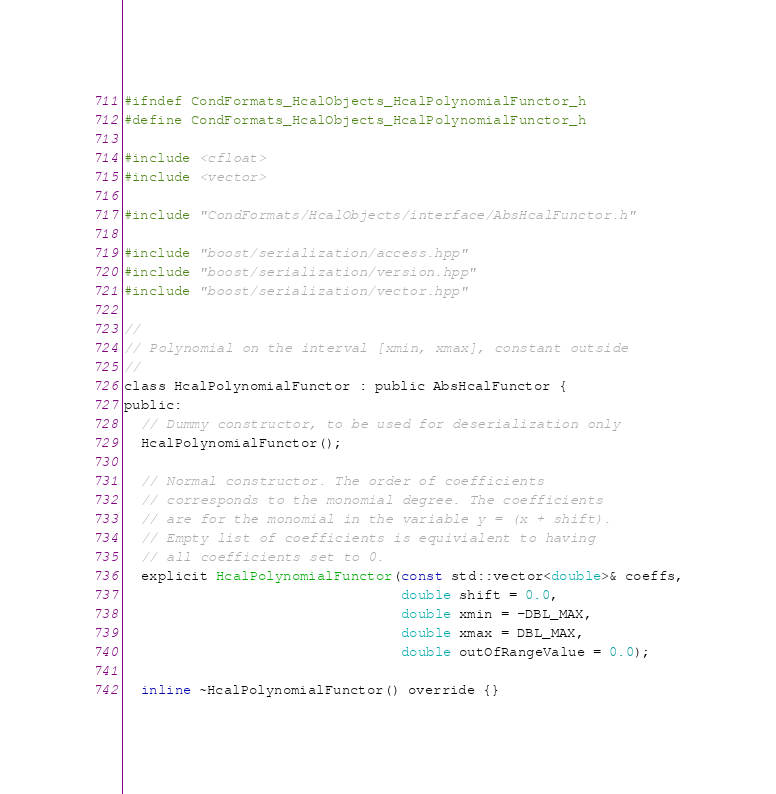<code> <loc_0><loc_0><loc_500><loc_500><_C_>#ifndef CondFormats_HcalObjects_HcalPolynomialFunctor_h
#define CondFormats_HcalObjects_HcalPolynomialFunctor_h

#include <cfloat>
#include <vector>

#include "CondFormats/HcalObjects/interface/AbsHcalFunctor.h"

#include "boost/serialization/access.hpp"
#include "boost/serialization/version.hpp"
#include "boost/serialization/vector.hpp"

//
// Polynomial on the interval [xmin, xmax], constant outside
//
class HcalPolynomialFunctor : public AbsHcalFunctor {
public:
  // Dummy constructor, to be used for deserialization only
  HcalPolynomialFunctor();

  // Normal constructor. The order of coefficients
  // corresponds to the monomial degree. The coefficients
  // are for the monomial in the variable y = (x + shift).
  // Empty list of coefficients is equivialent to having
  // all coefficients set to 0.
  explicit HcalPolynomialFunctor(const std::vector<double>& coeffs,
                                 double shift = 0.0,
                                 double xmin = -DBL_MAX,
                                 double xmax = DBL_MAX,
                                 double outOfRangeValue = 0.0);

  inline ~HcalPolynomialFunctor() override {}
</code> 